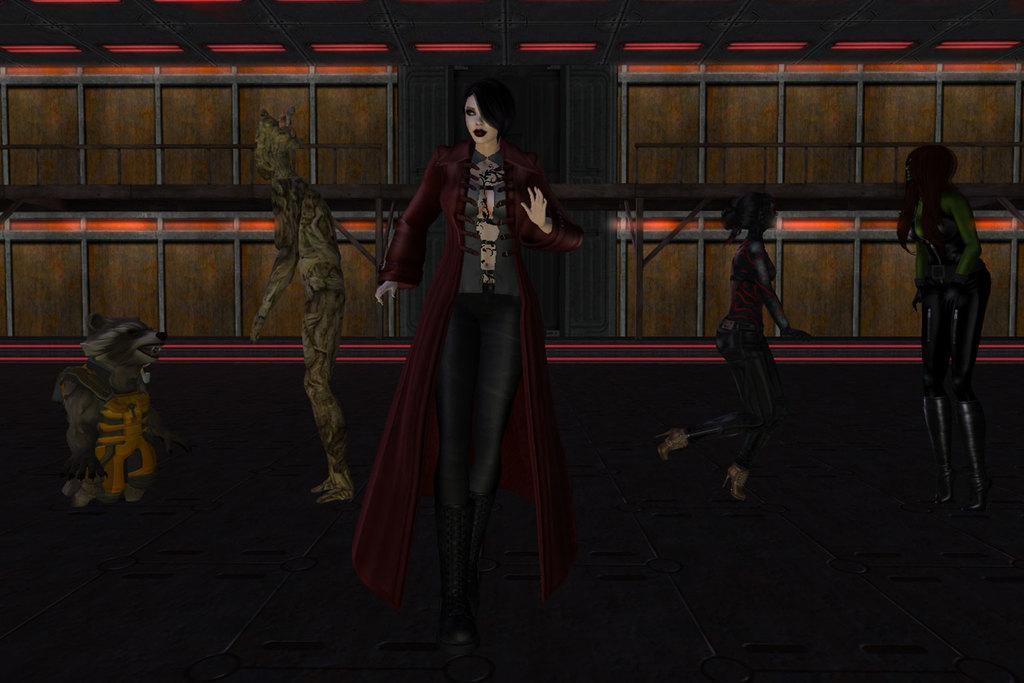Could you give a brief overview of what you see in this image? This is an animated image. Here I can see few people. On the left side there is an animal. In the background, I can see the wall. 